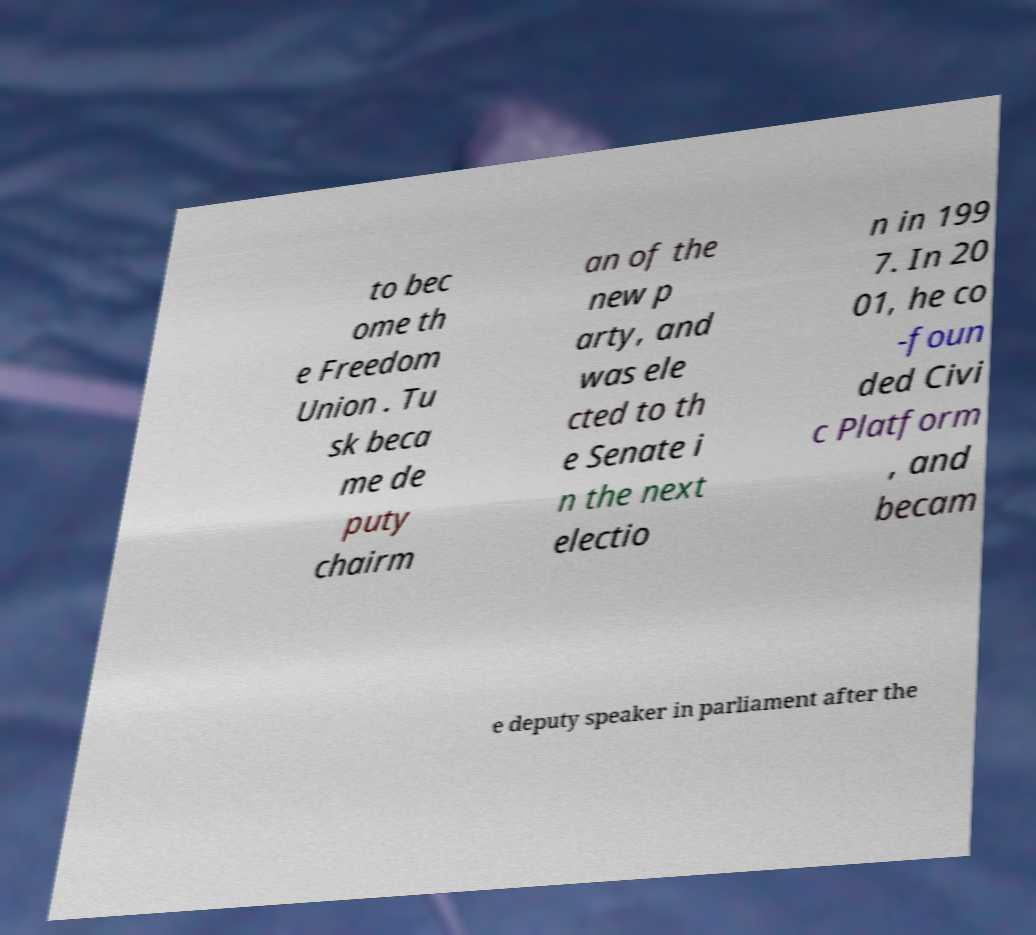There's text embedded in this image that I need extracted. Can you transcribe it verbatim? to bec ome th e Freedom Union . Tu sk beca me de puty chairm an of the new p arty, and was ele cted to th e Senate i n the next electio n in 199 7. In 20 01, he co -foun ded Civi c Platform , and becam e deputy speaker in parliament after the 